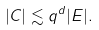<formula> <loc_0><loc_0><loc_500><loc_500>| C | \lesssim q ^ { d } | E | .</formula> 